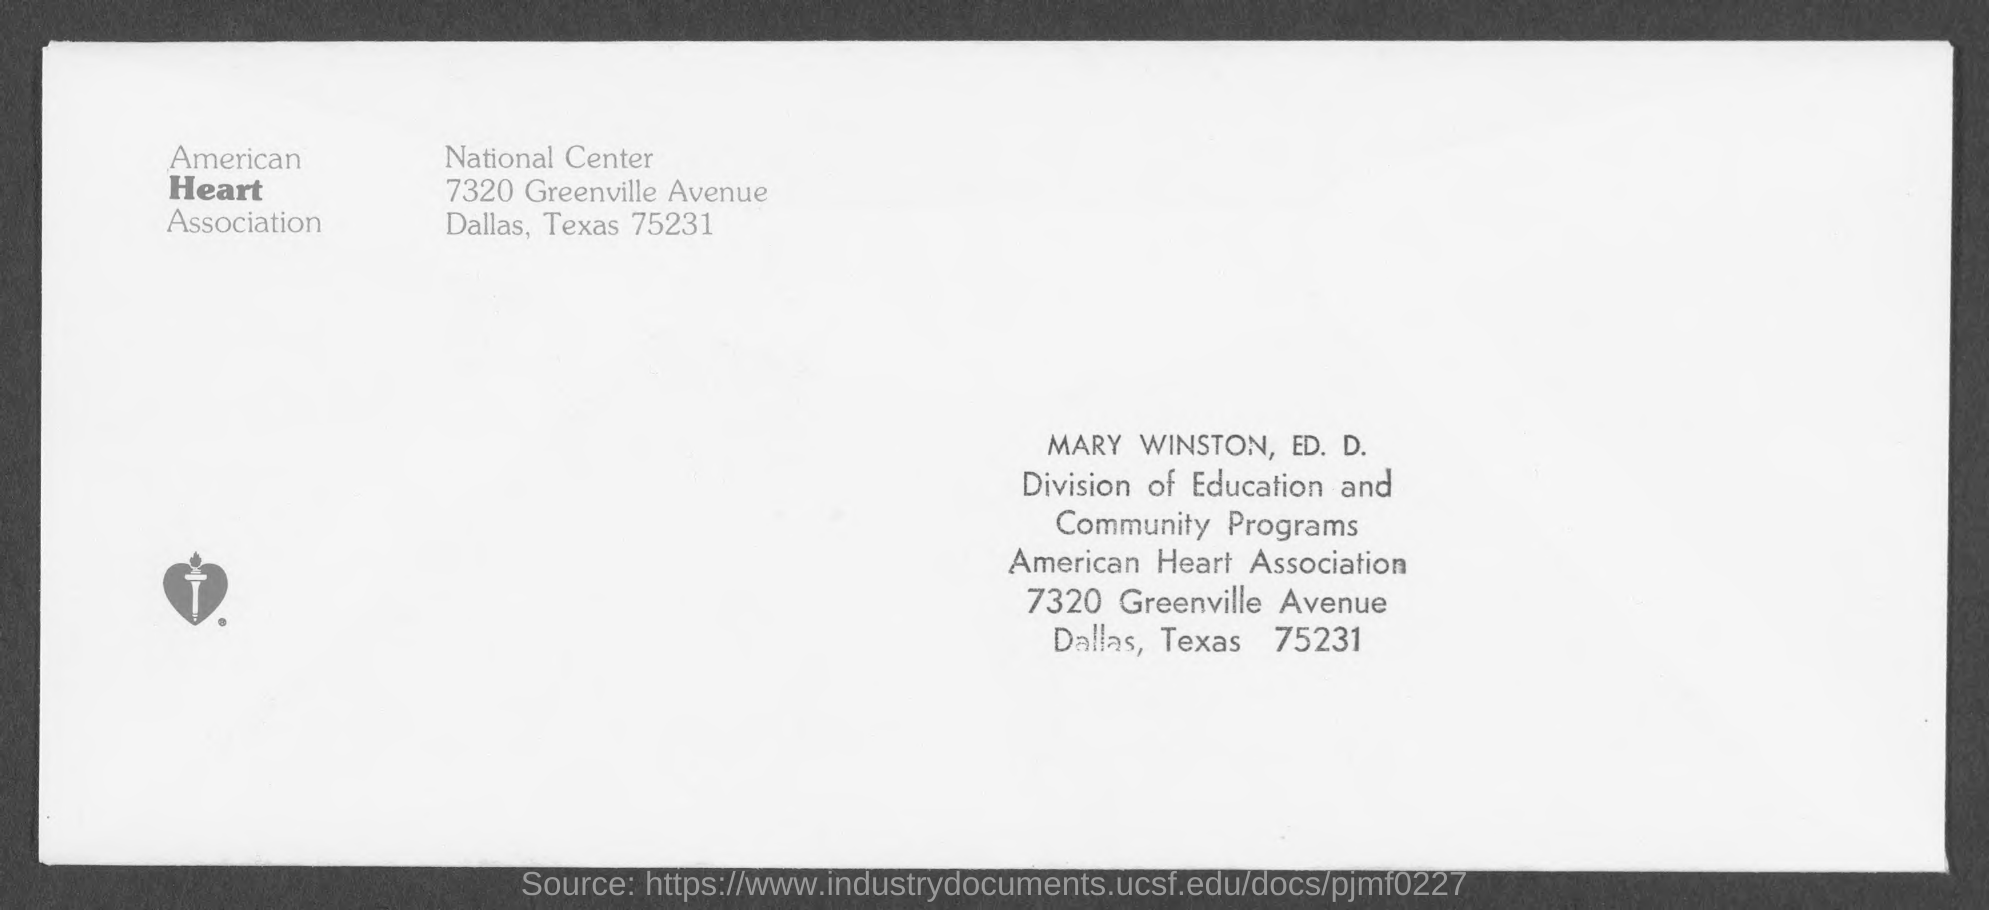Indicate a few pertinent items in this graphic. The American Heart Association is located in Dallas, Texas. This letter is written to Mary Winston. 